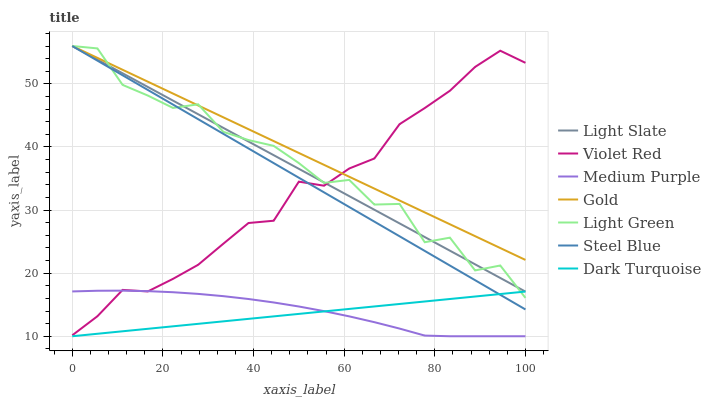Does Dark Turquoise have the minimum area under the curve?
Answer yes or no. Yes. Does Gold have the maximum area under the curve?
Answer yes or no. Yes. Does Light Slate have the minimum area under the curve?
Answer yes or no. No. Does Light Slate have the maximum area under the curve?
Answer yes or no. No. Is Dark Turquoise the smoothest?
Answer yes or no. Yes. Is Light Green the roughest?
Answer yes or no. Yes. Is Gold the smoothest?
Answer yes or no. No. Is Gold the roughest?
Answer yes or no. No. Does Light Slate have the lowest value?
Answer yes or no. No. Does Light Green have the highest value?
Answer yes or no. Yes. Does Dark Turquoise have the highest value?
Answer yes or no. No. Is Dark Turquoise less than Violet Red?
Answer yes or no. Yes. Is Gold greater than Medium Purple?
Answer yes or no. Yes. Does Light Slate intersect Steel Blue?
Answer yes or no. Yes. Is Light Slate less than Steel Blue?
Answer yes or no. No. Is Light Slate greater than Steel Blue?
Answer yes or no. No. Does Dark Turquoise intersect Violet Red?
Answer yes or no. No. 